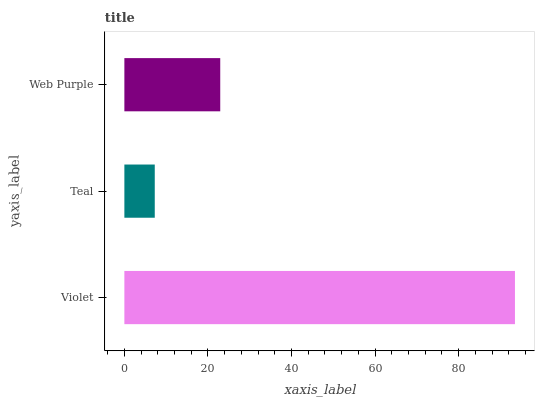Is Teal the minimum?
Answer yes or no. Yes. Is Violet the maximum?
Answer yes or no. Yes. Is Web Purple the minimum?
Answer yes or no. No. Is Web Purple the maximum?
Answer yes or no. No. Is Web Purple greater than Teal?
Answer yes or no. Yes. Is Teal less than Web Purple?
Answer yes or no. Yes. Is Teal greater than Web Purple?
Answer yes or no. No. Is Web Purple less than Teal?
Answer yes or no. No. Is Web Purple the high median?
Answer yes or no. Yes. Is Web Purple the low median?
Answer yes or no. Yes. Is Violet the high median?
Answer yes or no. No. Is Teal the low median?
Answer yes or no. No. 